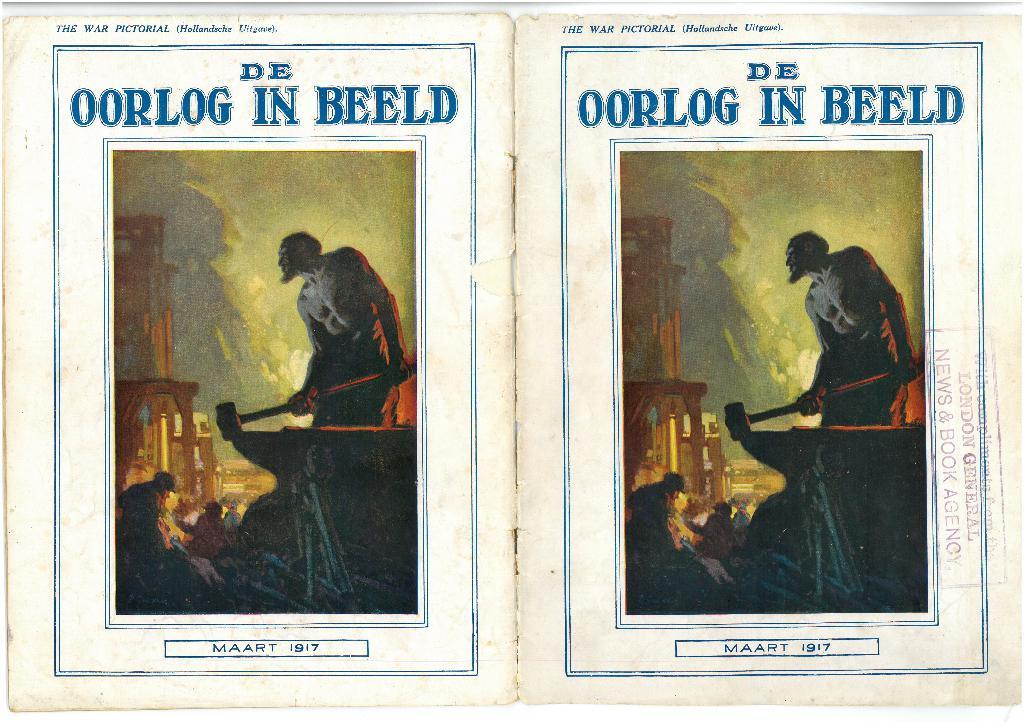What comes after the word oorlog?
Offer a very short reply. In. What is the title of this work?
Provide a short and direct response. De oorlog in beeld. 